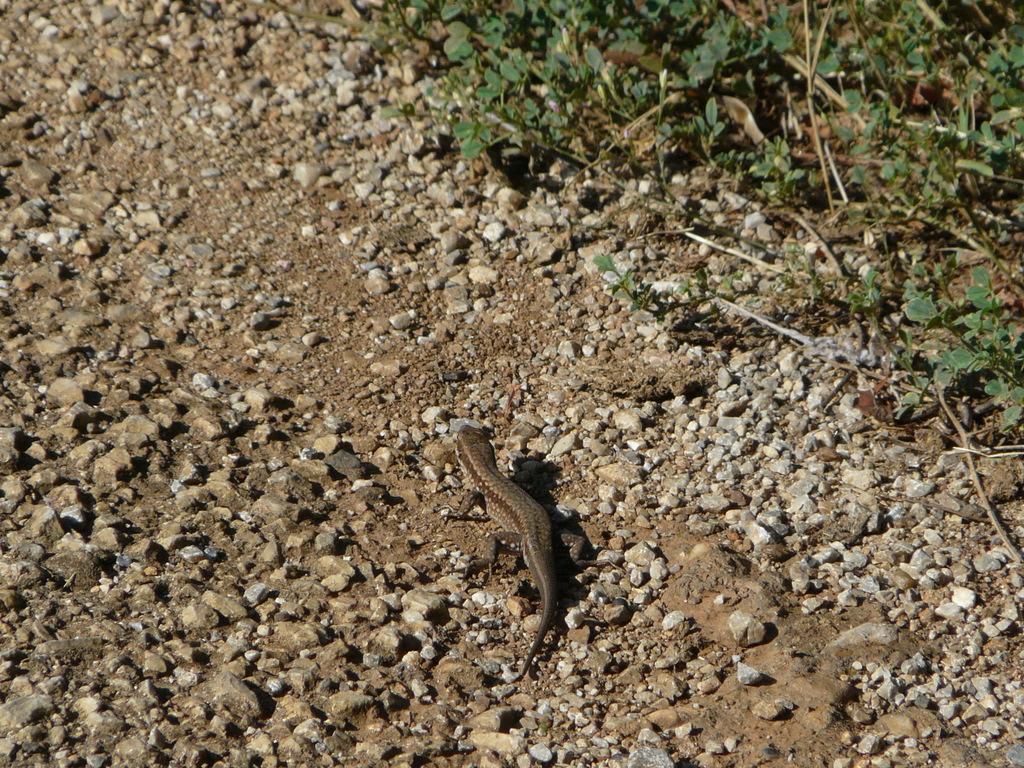Please provide a concise description of this image. In this image we can see an animal on the ground. In the background, we can see some plants. 